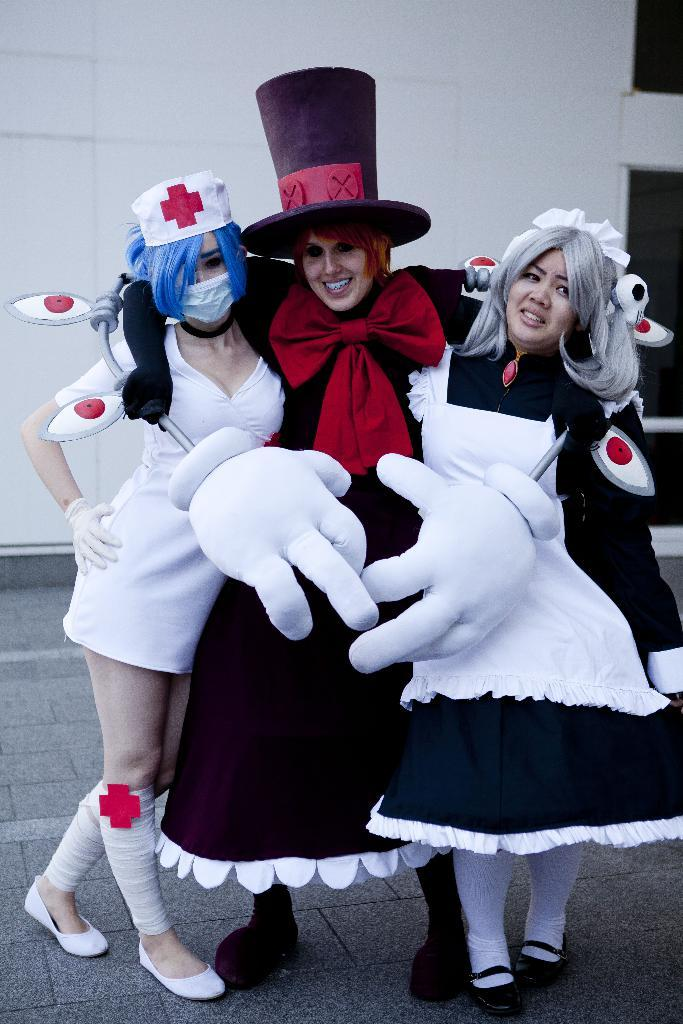How many people are present in the image? There are three people in the image. What are the people wearing? The three people are wearing costumes. What can be seen in the background of the image? There is a wall in the background of the image. What is the texture of the year in the image? There is no year present in the image, and therefore no texture can be determined. 